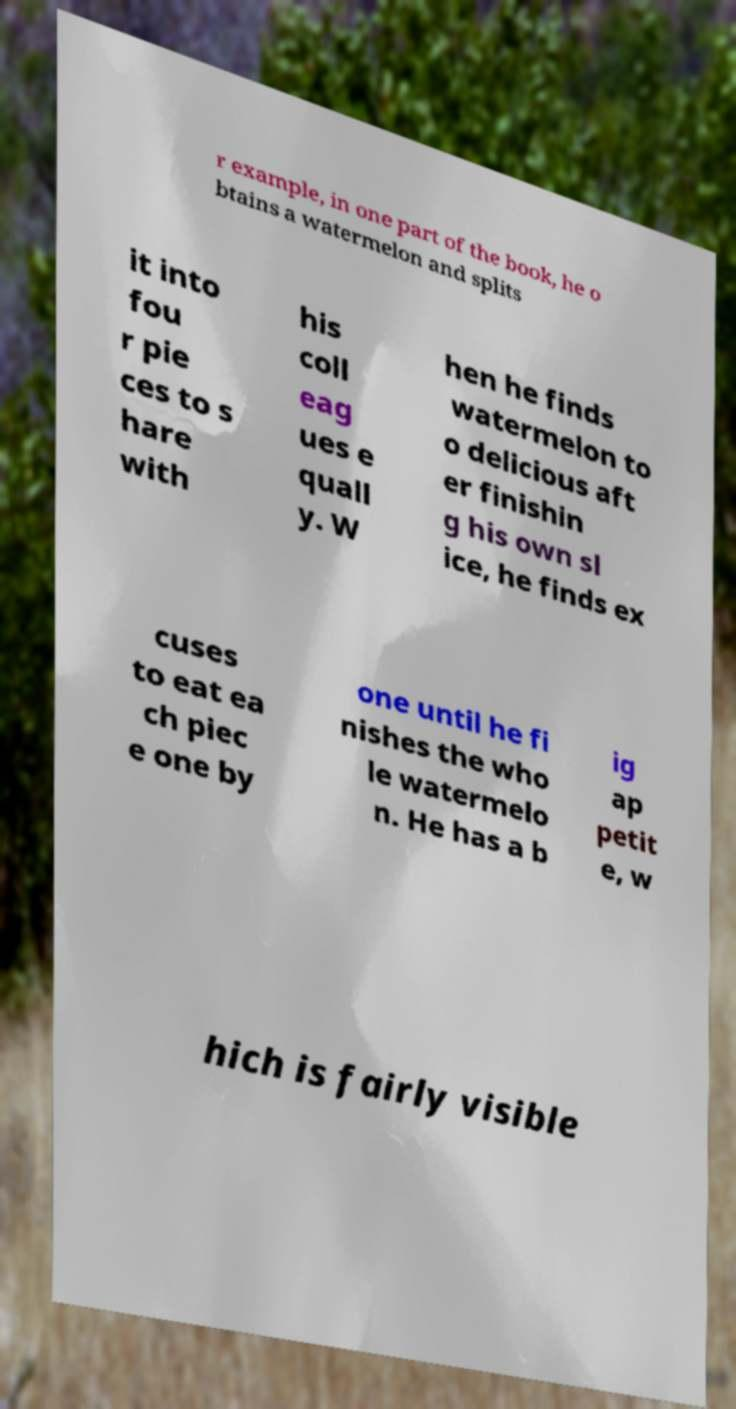Can you accurately transcribe the text from the provided image for me? r example, in one part of the book, he o btains a watermelon and splits it into fou r pie ces to s hare with his coll eag ues e quall y. W hen he finds watermelon to o delicious aft er finishin g his own sl ice, he finds ex cuses to eat ea ch piec e one by one until he fi nishes the who le watermelo n. He has a b ig ap petit e, w hich is fairly visible 